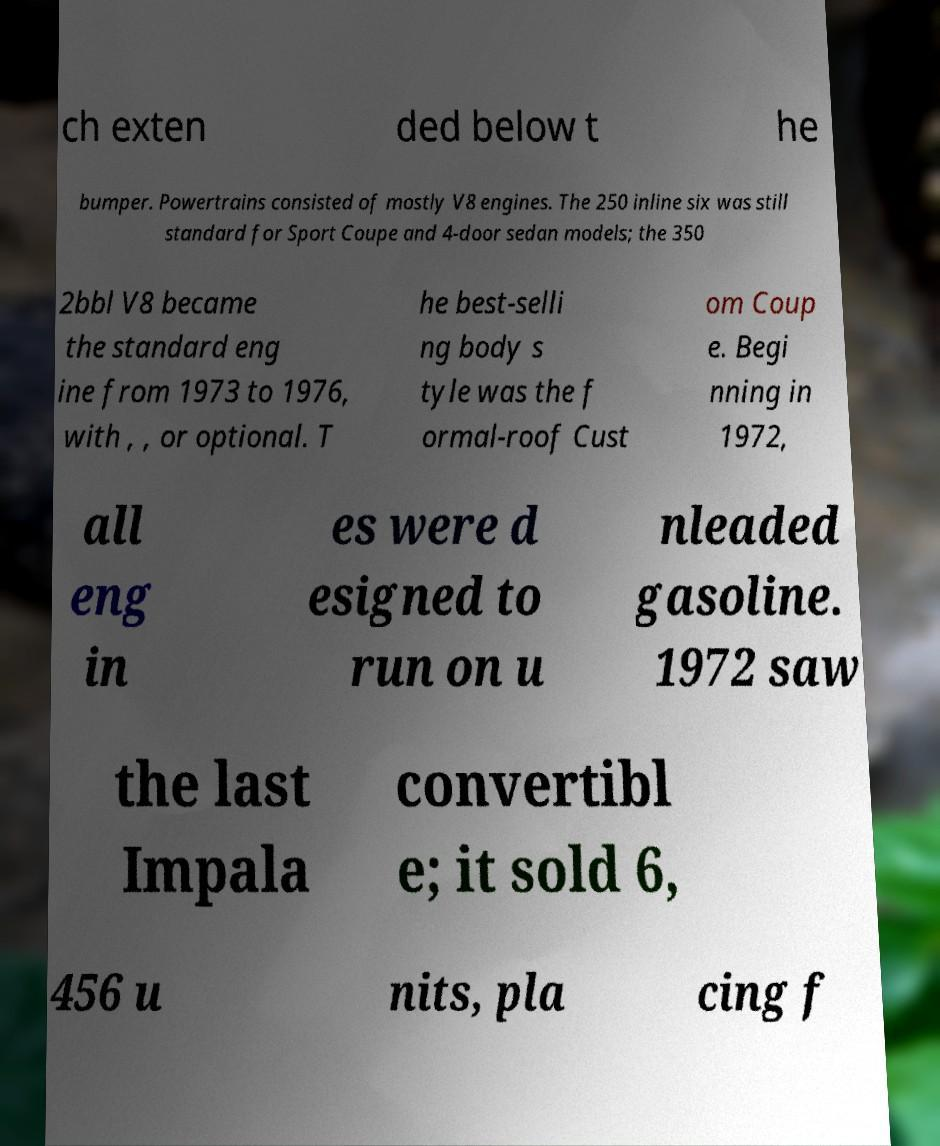For documentation purposes, I need the text within this image transcribed. Could you provide that? ch exten ded below t he bumper. Powertrains consisted of mostly V8 engines. The 250 inline six was still standard for Sport Coupe and 4-door sedan models; the 350 2bbl V8 became the standard eng ine from 1973 to 1976, with , , or optional. T he best-selli ng body s tyle was the f ormal-roof Cust om Coup e. Begi nning in 1972, all eng in es were d esigned to run on u nleaded gasoline. 1972 saw the last Impala convertibl e; it sold 6, 456 u nits, pla cing f 